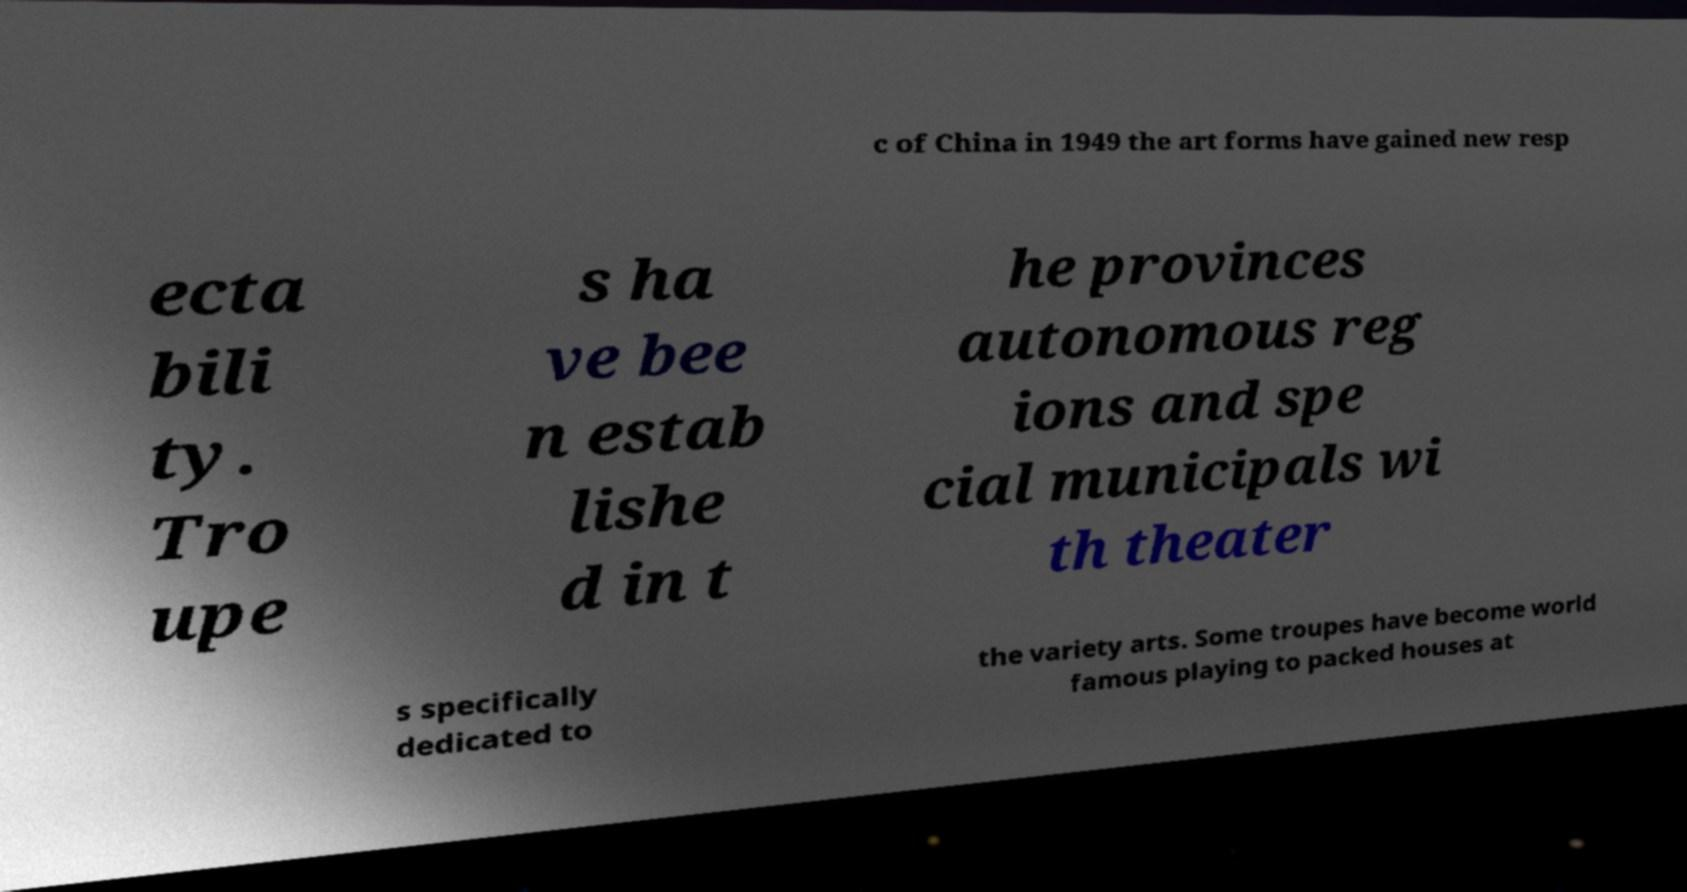Could you assist in decoding the text presented in this image and type it out clearly? c of China in 1949 the art forms have gained new resp ecta bili ty. Tro upe s ha ve bee n estab lishe d in t he provinces autonomous reg ions and spe cial municipals wi th theater s specifically dedicated to the variety arts. Some troupes have become world famous playing to packed houses at 